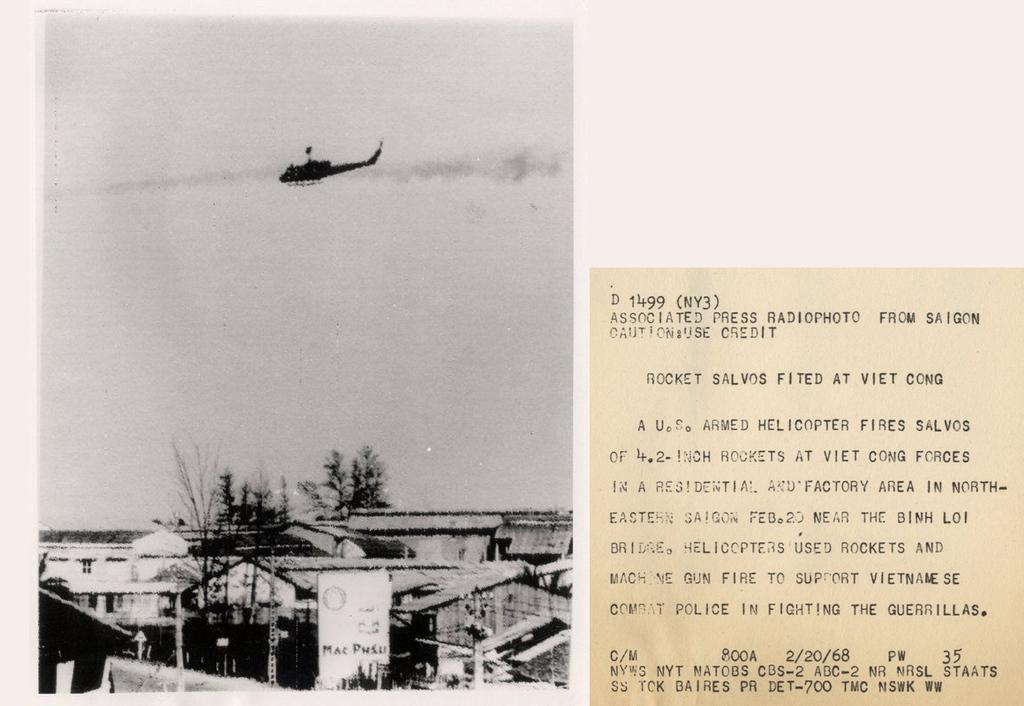How many posts can be seen in the image? There are two posts in the image. What is on one of the posts? There is a poster on one of the posts. What type of structures can be seen in the image? Buildings are visible in the image. What else can be found in the image besides buildings? Trees and poles are present in the image. Is there any transportation visible in the image? Yes, there is an airplane flying in the image. Are there any other posters with text in the image? Yes, there is another poster with text in the image. Can you tell me how many worms are crawling on the pot in the image? There is no pot or worms present in the image. What unit of measurement is used to determine the size of the pot in the image? There is no pot in the image, so there is no need to measure its size. 